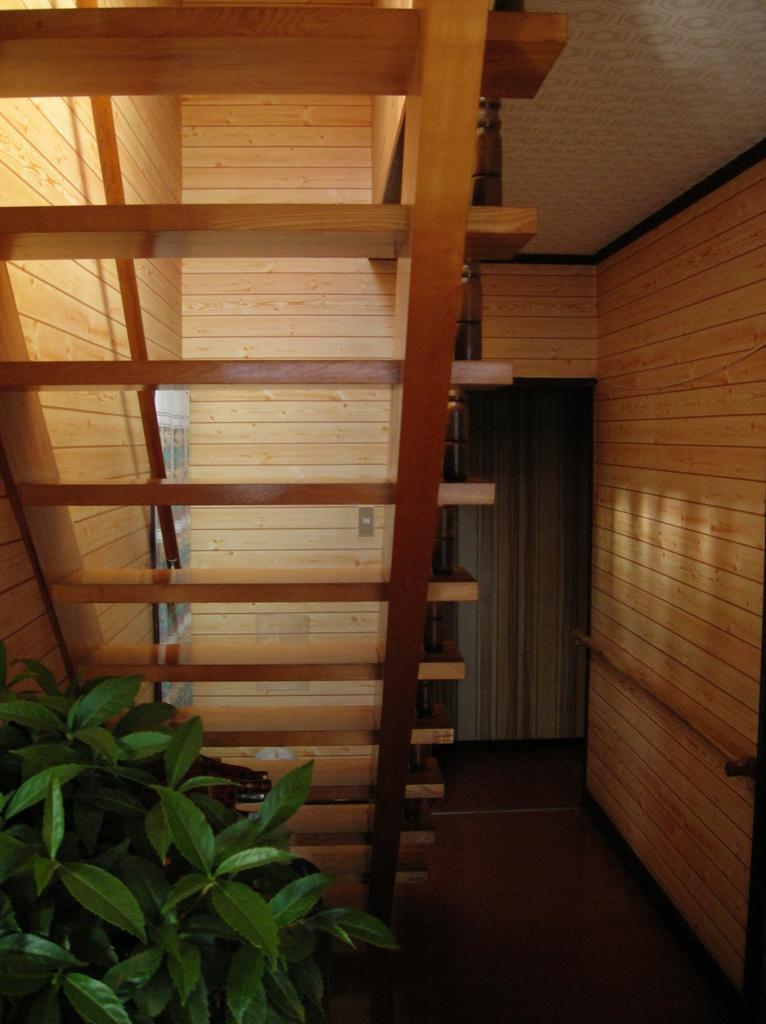Please provide a concise description of this image. In this image I can see a houseplant, staircase and also a wall. This image is taken, maybe in a house. 